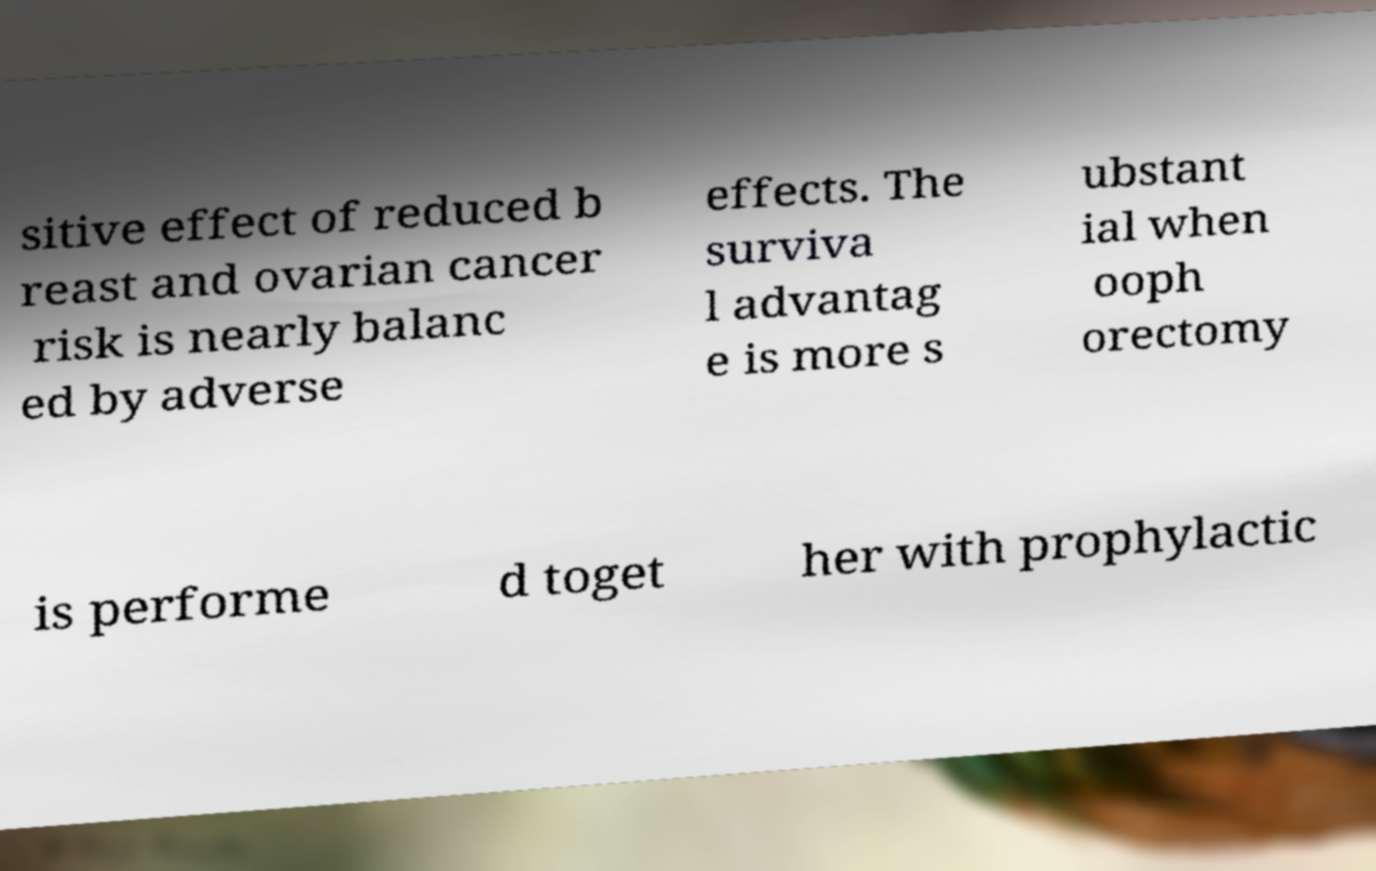Can you read and provide the text displayed in the image?This photo seems to have some interesting text. Can you extract and type it out for me? sitive effect of reduced b reast and ovarian cancer risk is nearly balanc ed by adverse effects. The surviva l advantag e is more s ubstant ial when ooph orectomy is performe d toget her with prophylactic 